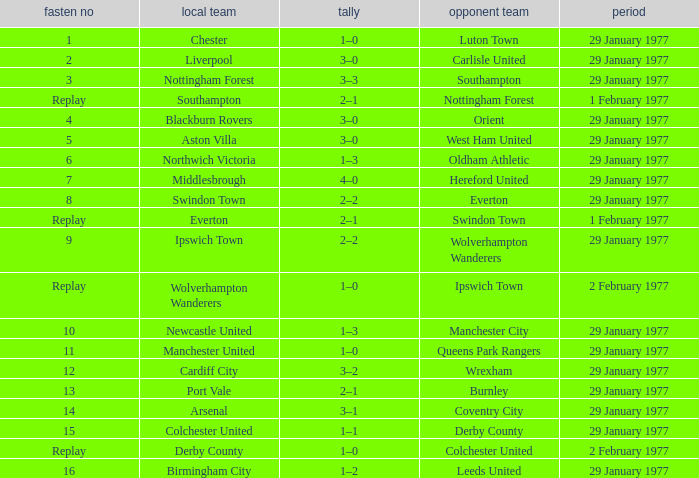What is the score in the Liverpool home game? 3–0. 